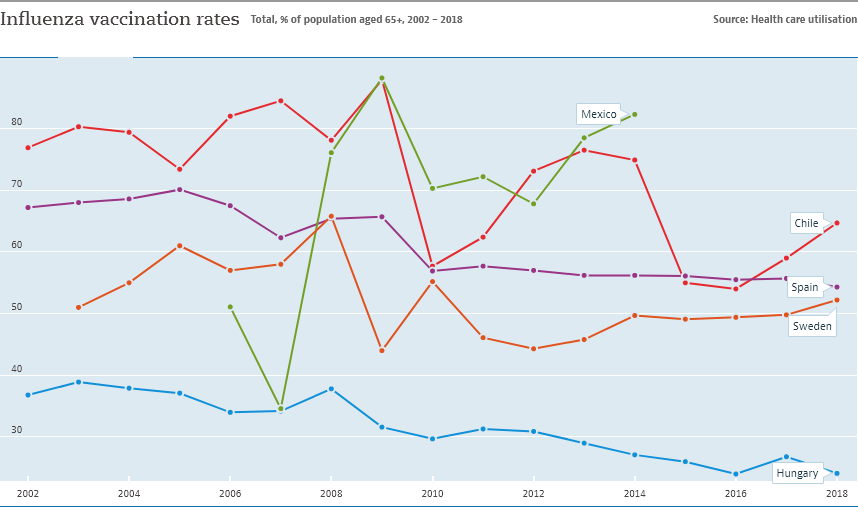Draw attention to some important aspects in this diagram. In 2008, the line graph of Mexico showed its highest peak. The inflation rate of Sweden is higher than that of Hungary over the years, according to the provided data. 